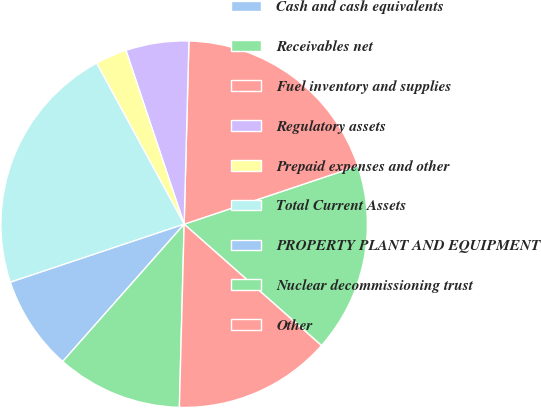Convert chart. <chart><loc_0><loc_0><loc_500><loc_500><pie_chart><fcel>Cash and cash equivalents<fcel>Receivables net<fcel>Fuel inventory and supplies<fcel>Regulatory assets<fcel>Prepaid expenses and other<fcel>Total Current Assets<fcel>PROPERTY PLANT AND EQUIPMENT<fcel>Nuclear decommissioning trust<fcel>Other<nl><fcel>0.01%<fcel>16.66%<fcel>19.44%<fcel>5.56%<fcel>2.78%<fcel>22.21%<fcel>8.34%<fcel>11.11%<fcel>13.89%<nl></chart> 